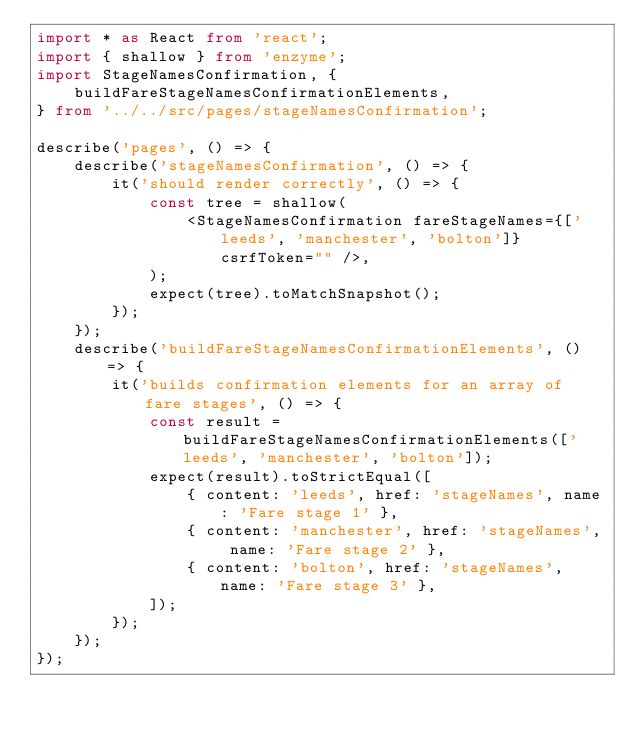Convert code to text. <code><loc_0><loc_0><loc_500><loc_500><_TypeScript_>import * as React from 'react';
import { shallow } from 'enzyme';
import StageNamesConfirmation, {
    buildFareStageNamesConfirmationElements,
} from '../../src/pages/stageNamesConfirmation';

describe('pages', () => {
    describe('stageNamesConfirmation', () => {
        it('should render correctly', () => {
            const tree = shallow(
                <StageNamesConfirmation fareStageNames={['leeds', 'manchester', 'bolton']} csrfToken="" />,
            );
            expect(tree).toMatchSnapshot();
        });
    });
    describe('buildFareStageNamesConfirmationElements', () => {
        it('builds confirmation elements for an array of fare stages', () => {
            const result = buildFareStageNamesConfirmationElements(['leeds', 'manchester', 'bolton']);
            expect(result).toStrictEqual([
                { content: 'leeds', href: 'stageNames', name: 'Fare stage 1' },
                { content: 'manchester', href: 'stageNames', name: 'Fare stage 2' },
                { content: 'bolton', href: 'stageNames', name: 'Fare stage 3' },
            ]);
        });
    });
});
</code> 